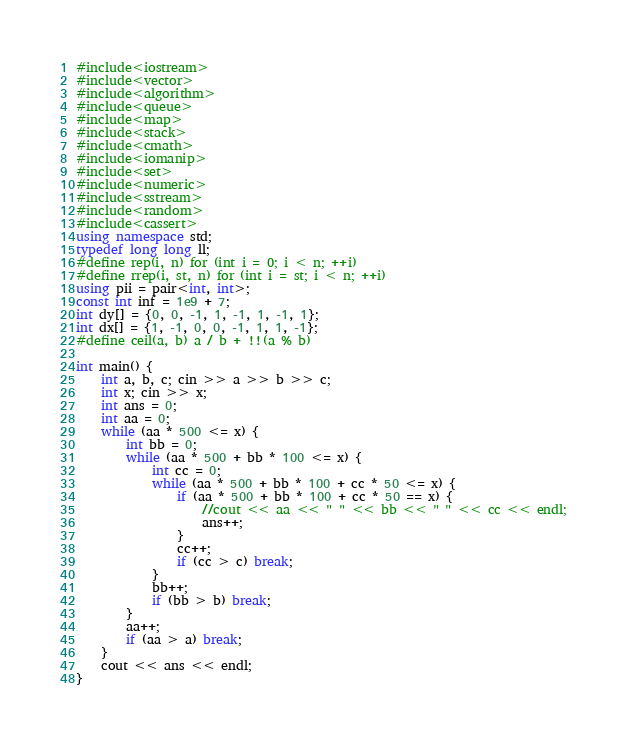<code> <loc_0><loc_0><loc_500><loc_500><_C++_>#include<iostream>
#include<vector>
#include<algorithm>
#include<queue>
#include<map>
#include<stack>
#include<cmath>
#include<iomanip>
#include<set>
#include<numeric>
#include<sstream>
#include<random>
#include<cassert>
using namespace std;
typedef long long ll;
#define rep(i, n) for (int i = 0; i < n; ++i)
#define rrep(i, st, n) for (int i = st; i < n; ++i)
using pii = pair<int, int>;
const int inf = 1e9 + 7;
int dy[] = {0, 0, -1, 1, -1, 1, -1, 1};
int dx[] = {1, -1, 0, 0, -1, 1, 1, -1};
#define ceil(a, b) a / b + !!(a % b)

int main() {
    int a, b, c; cin >> a >> b >> c;
    int x; cin >> x;
    int ans = 0;
    int aa = 0;
    while (aa * 500 <= x) {
        int bb = 0;
        while (aa * 500 + bb * 100 <= x) {
            int cc = 0;
            while (aa * 500 + bb * 100 + cc * 50 <= x) {
                if (aa * 500 + bb * 100 + cc * 50 == x) {
                    //cout << aa << " " << bb << " " << cc << endl;
                    ans++;
                }
                cc++;
                if (cc > c) break;
            }
            bb++;
            if (bb > b) break;
        }
        aa++;
        if (aa > a) break;
    }
    cout << ans << endl;
}
</code> 